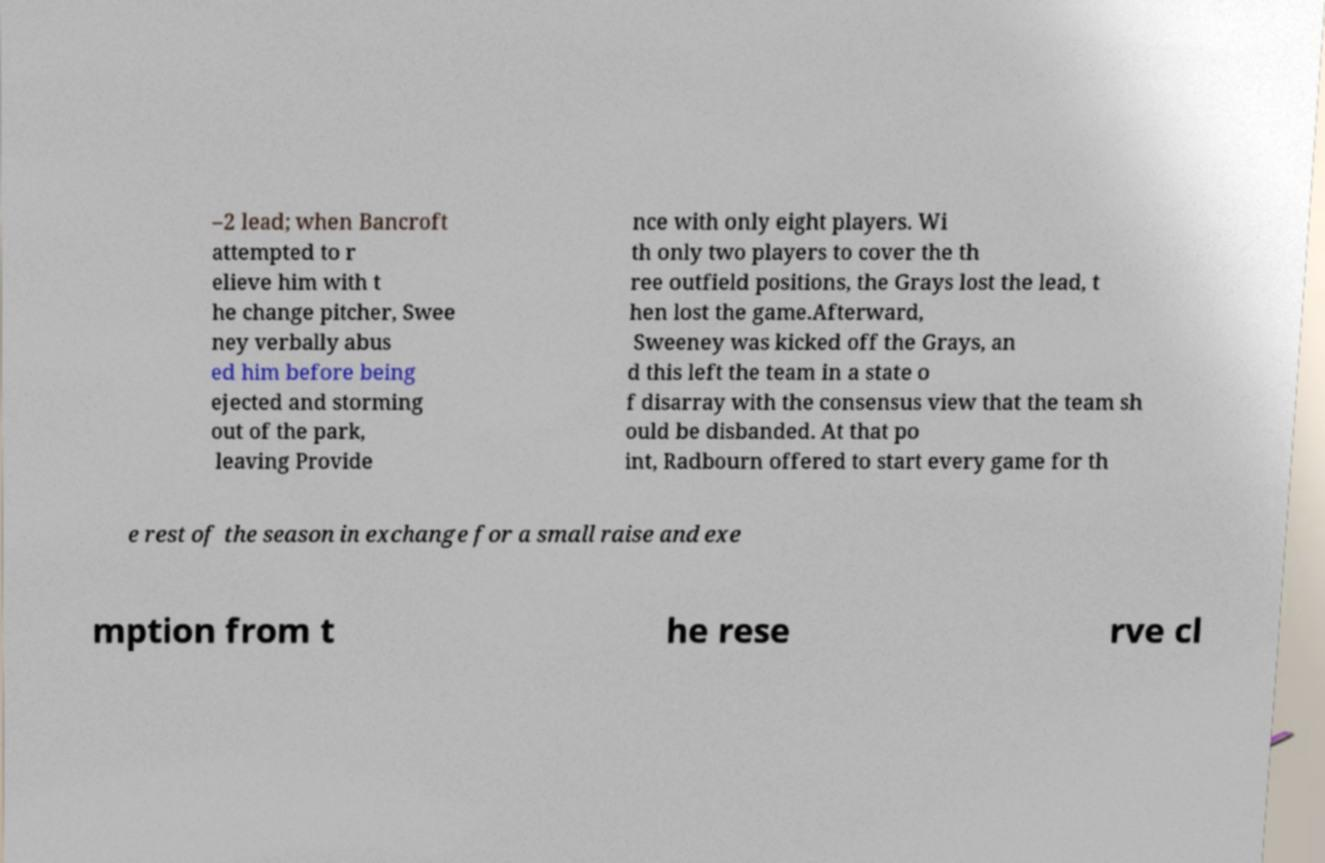What messages or text are displayed in this image? I need them in a readable, typed format. –2 lead; when Bancroft attempted to r elieve him with t he change pitcher, Swee ney verbally abus ed him before being ejected and storming out of the park, leaving Provide nce with only eight players. Wi th only two players to cover the th ree outfield positions, the Grays lost the lead, t hen lost the game.Afterward, Sweeney was kicked off the Grays, an d this left the team in a state o f disarray with the consensus view that the team sh ould be disbanded. At that po int, Radbourn offered to start every game for th e rest of the season in exchange for a small raise and exe mption from t he rese rve cl 